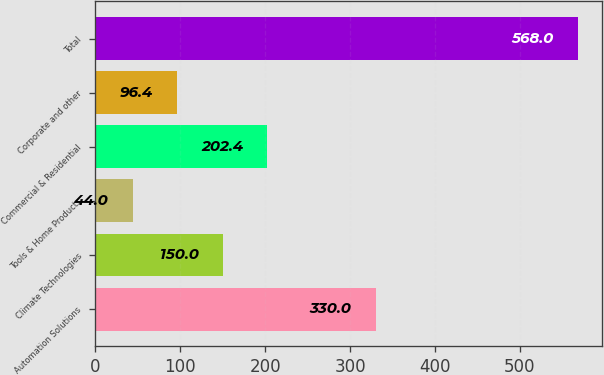<chart> <loc_0><loc_0><loc_500><loc_500><bar_chart><fcel>Automation Solutions<fcel>Climate Technologies<fcel>Tools & Home Products<fcel>Commercial & Residential<fcel>Corporate and other<fcel>Total<nl><fcel>330<fcel>150<fcel>44<fcel>202.4<fcel>96.4<fcel>568<nl></chart> 